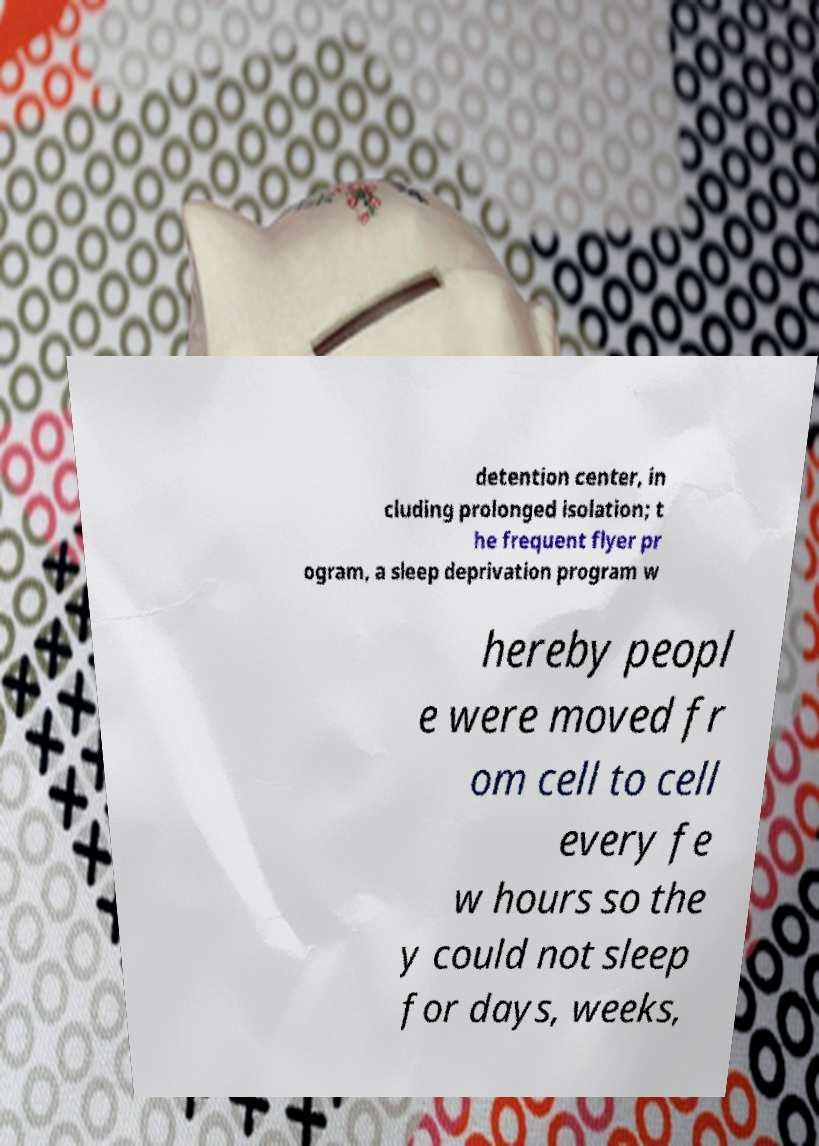For documentation purposes, I need the text within this image transcribed. Could you provide that? detention center, in cluding prolonged isolation; t he frequent flyer pr ogram, a sleep deprivation program w hereby peopl e were moved fr om cell to cell every fe w hours so the y could not sleep for days, weeks, 